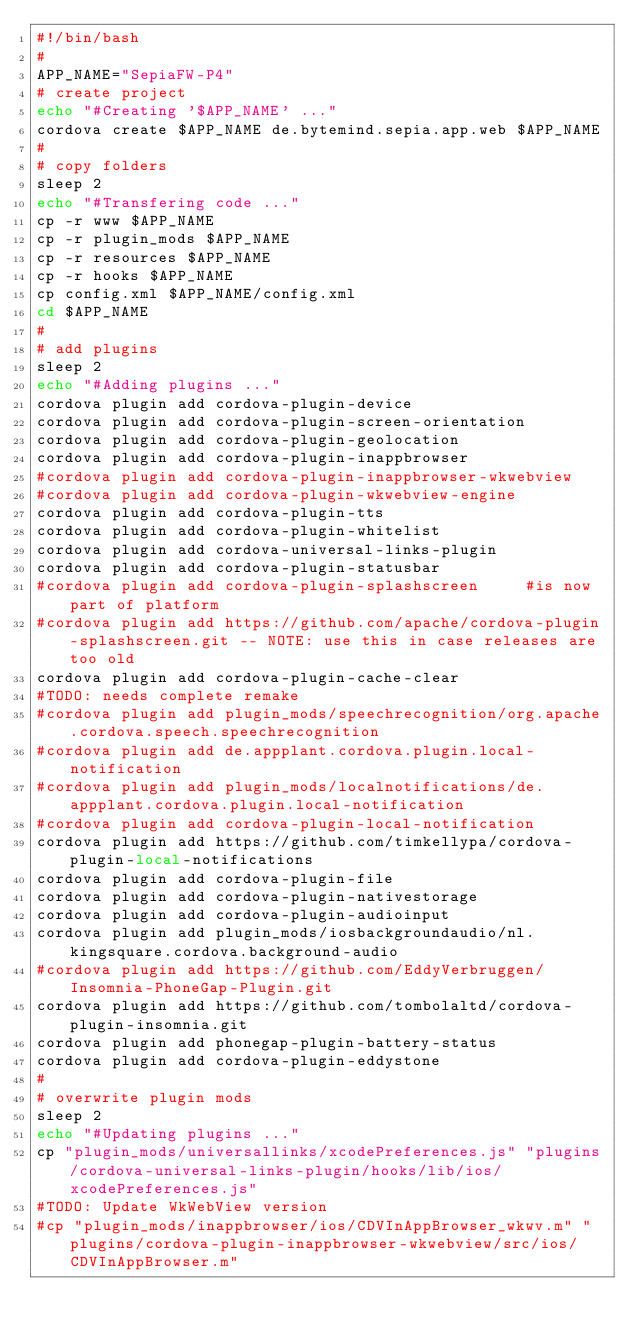Convert code to text. <code><loc_0><loc_0><loc_500><loc_500><_Bash_>#!/bin/bash
#
APP_NAME="SepiaFW-P4"
# create project
echo "#Creating '$APP_NAME' ..."
cordova create $APP_NAME de.bytemind.sepia.app.web $APP_NAME
#
# copy folders
sleep 2
echo "#Transfering code ..."
cp -r www $APP_NAME
cp -r plugin_mods $APP_NAME
cp -r resources $APP_NAME
cp -r hooks $APP_NAME
cp config.xml $APP_NAME/config.xml
cd $APP_NAME
#
# add plugins
sleep 2
echo "#Adding plugins ..."
cordova plugin add cordova-plugin-device
cordova plugin add cordova-plugin-screen-orientation
cordova plugin add cordova-plugin-geolocation
cordova plugin add cordova-plugin-inappbrowser
#cordova plugin add cordova-plugin-inappbrowser-wkwebview
#cordova plugin add cordova-plugin-wkwebview-engine
cordova plugin add cordova-plugin-tts
cordova plugin add cordova-plugin-whitelist
cordova plugin add cordova-universal-links-plugin
cordova plugin add cordova-plugin-statusbar
#cordova plugin add cordova-plugin-splashscreen		#is now part of platform
#cordova plugin add https://github.com/apache/cordova-plugin-splashscreen.git -- NOTE: use this in case releases are too old
cordova plugin add cordova-plugin-cache-clear
#TODO: needs complete remake
#cordova plugin add plugin_mods/speechrecognition/org.apache.cordova.speech.speechrecognition
#cordova plugin add de.appplant.cordova.plugin.local-notification
#cordova plugin add plugin_mods/localnotifications/de.appplant.cordova.plugin.local-notification
#cordova plugin add cordova-plugin-local-notification
cordova plugin add https://github.com/timkellypa/cordova-plugin-local-notifications
cordova plugin add cordova-plugin-file
cordova plugin add cordova-plugin-nativestorage
cordova plugin add cordova-plugin-audioinput
cordova plugin add plugin_mods/iosbackgroundaudio/nl.kingsquare.cordova.background-audio
#cordova plugin add https://github.com/EddyVerbruggen/Insomnia-PhoneGap-Plugin.git
cordova plugin add https://github.com/tombolaltd/cordova-plugin-insomnia.git
cordova plugin add phonegap-plugin-battery-status
cordova plugin add cordova-plugin-eddystone
#
# overwrite plugin mods
sleep 2
echo "#Updating plugins ..."
cp "plugin_mods/universallinks/xcodePreferences.js" "plugins/cordova-universal-links-plugin/hooks/lib/ios/xcodePreferences.js"
#TODO: Update WkWebView version
#cp "plugin_mods/inappbrowser/ios/CDVInAppBrowser_wkwv.m" "plugins/cordova-plugin-inappbrowser-wkwebview/src/ios/CDVInAppBrowser.m"</code> 